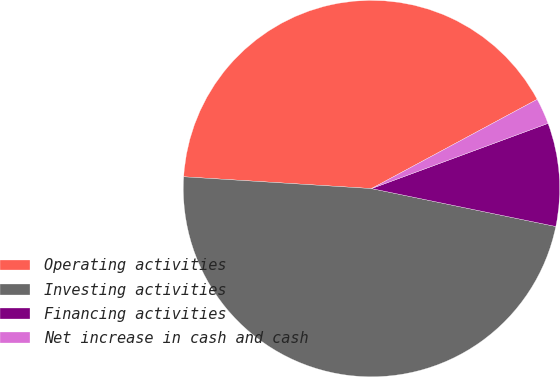<chart> <loc_0><loc_0><loc_500><loc_500><pie_chart><fcel>Operating activities<fcel>Investing activities<fcel>Financing activities<fcel>Net increase in cash and cash<nl><fcel>41.14%<fcel>47.77%<fcel>8.86%<fcel>2.23%<nl></chart> 